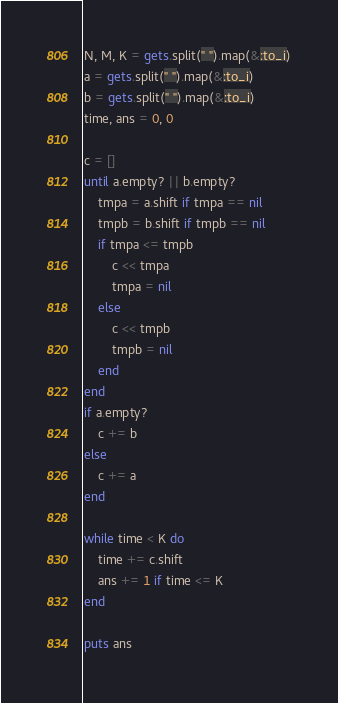Convert code to text. <code><loc_0><loc_0><loc_500><loc_500><_Ruby_>N, M, K = gets.split(" ").map(&:to_i)
a = gets.split(" ").map(&:to_i)
b = gets.split(" ").map(&:to_i)
time, ans = 0, 0

c = []
until a.empty? || b.empty?
    tmpa = a.shift if tmpa == nil 
    tmpb = b.shift if tmpb == nil 
    if tmpa <= tmpb 
        c << tmpa 
        tmpa = nil
    else
        c << tmpb 
        tmpb = nil
    end
end
if a.empty?
    c += b
else
    c += a
end

while time < K do
    time += c.shift
    ans += 1 if time <= K
end

puts ans
</code> 